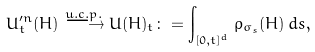<formula> <loc_0><loc_0><loc_500><loc_500>U _ { t } ^ { \prime n } ( H ) \stackrel { u . c . p . } { \longrightarrow } U ( H ) _ { t } \colon = \int _ { [ 0 , t ] ^ { d } } \rho _ { \sigma _ { s } } ( H ) \, d s ,</formula> 